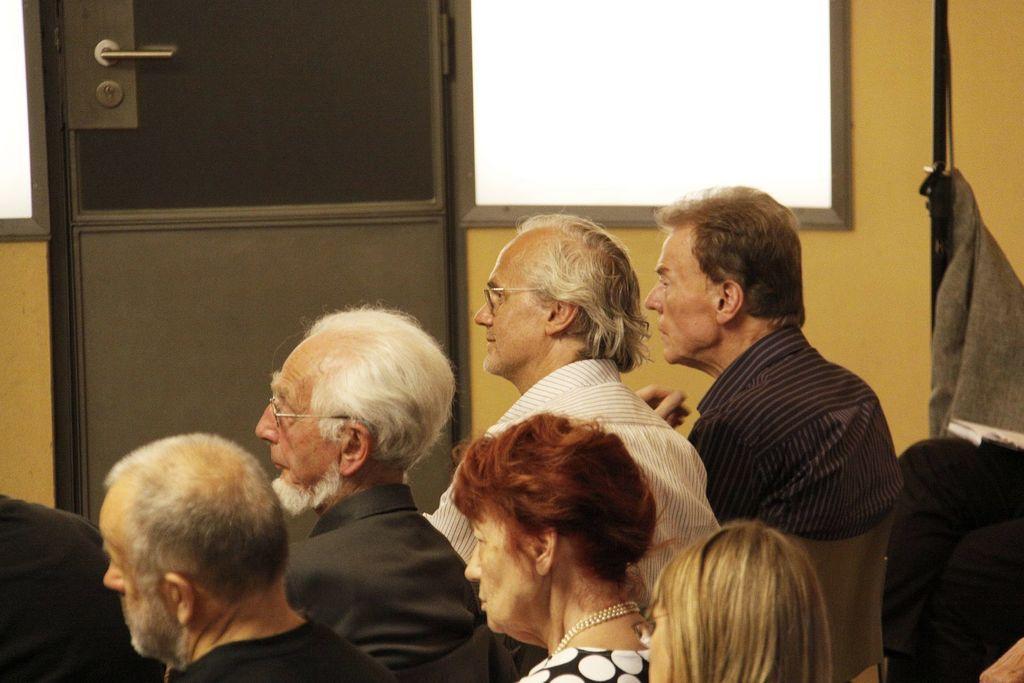Please provide a concise description of this image. In this picture I can see some people are sitting on the chairs and watching behind I can see doors, windows to the wall. 